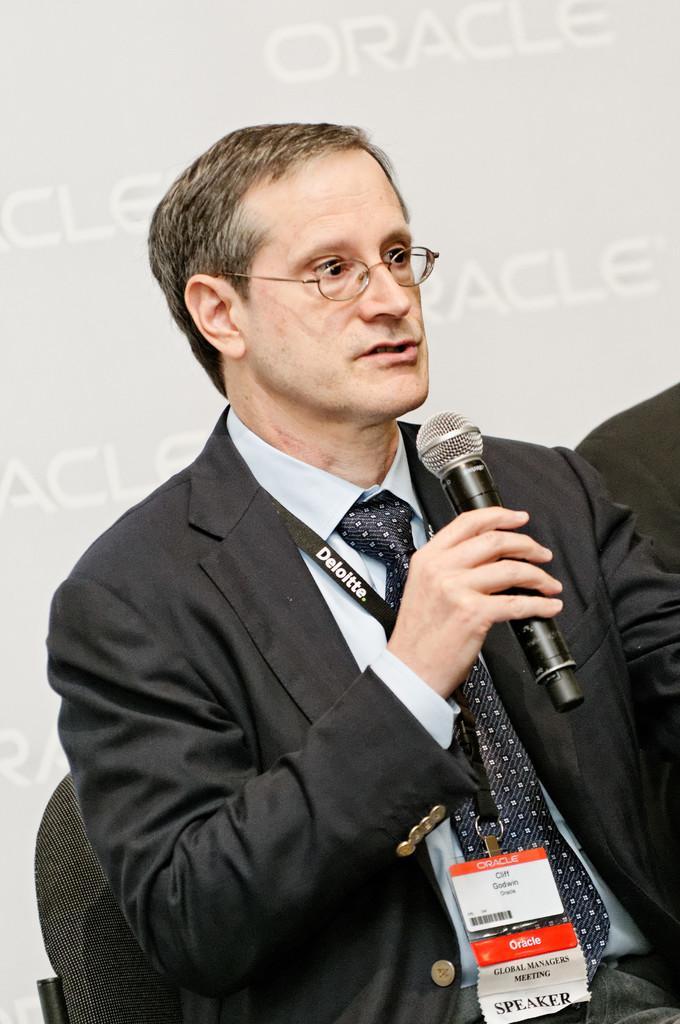How would you summarize this image in a sentence or two? In the image we can see there is a person who is sitting on chair and holding mic in his hand. 